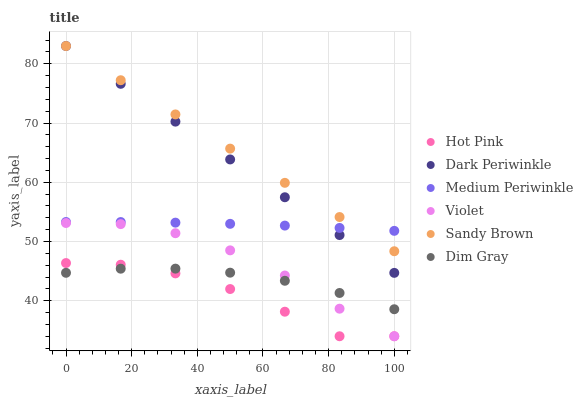Does Hot Pink have the minimum area under the curve?
Answer yes or no. Yes. Does Sandy Brown have the maximum area under the curve?
Answer yes or no. Yes. Does Medium Periwinkle have the minimum area under the curve?
Answer yes or no. No. Does Medium Periwinkle have the maximum area under the curve?
Answer yes or no. No. Is Dark Periwinkle the smoothest?
Answer yes or no. Yes. Is Hot Pink the roughest?
Answer yes or no. Yes. Is Medium Periwinkle the smoothest?
Answer yes or no. No. Is Medium Periwinkle the roughest?
Answer yes or no. No. Does Hot Pink have the lowest value?
Answer yes or no. Yes. Does Medium Periwinkle have the lowest value?
Answer yes or no. No. Does Dark Periwinkle have the highest value?
Answer yes or no. Yes. Does Hot Pink have the highest value?
Answer yes or no. No. Is Dim Gray less than Sandy Brown?
Answer yes or no. Yes. Is Medium Periwinkle greater than Hot Pink?
Answer yes or no. Yes. Does Dark Periwinkle intersect Sandy Brown?
Answer yes or no. Yes. Is Dark Periwinkle less than Sandy Brown?
Answer yes or no. No. Is Dark Periwinkle greater than Sandy Brown?
Answer yes or no. No. Does Dim Gray intersect Sandy Brown?
Answer yes or no. No. 